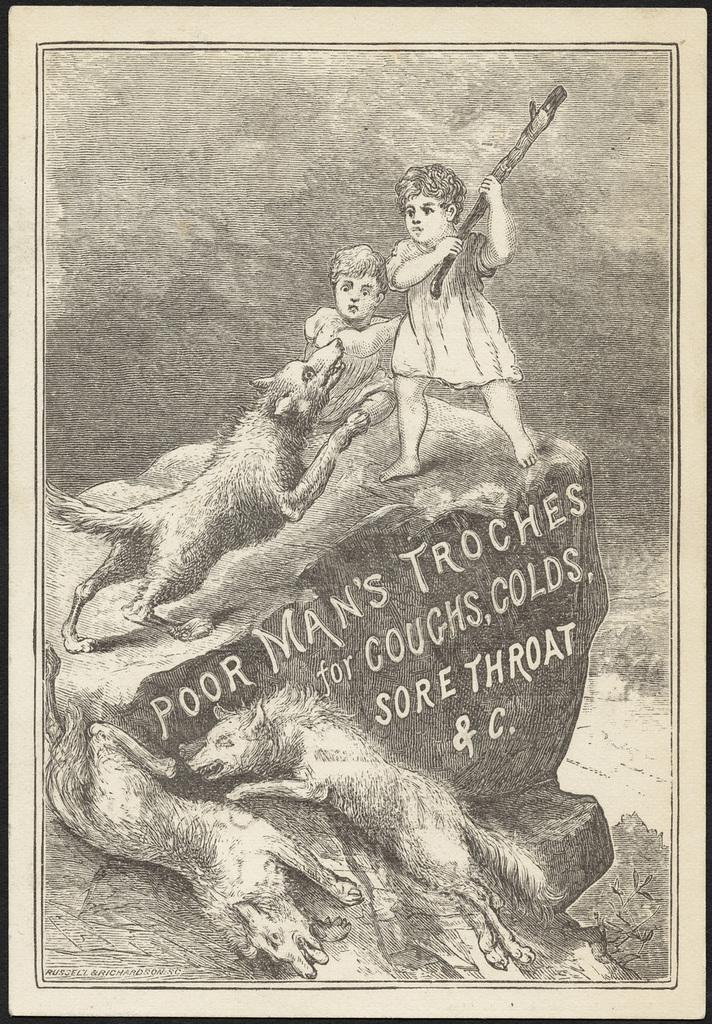What is the color scheme of the poster in the image? The poster is black and white. How many children are depicted in the poster? There are two children in the poster. What animals are present in the poster? There are foxes in the poster. What object can be seen in the poster? There is a rock in the poster. What else is featured on the poster besides the images? There is text in the poster. What type of attraction is depicted in the poster? There is no attraction depicted in the poster; it features two children, foxes, a rock, and text. What invention is being showcased in the poster? There is no invention showcased in the poster; it is a black and white poster with images and text. 